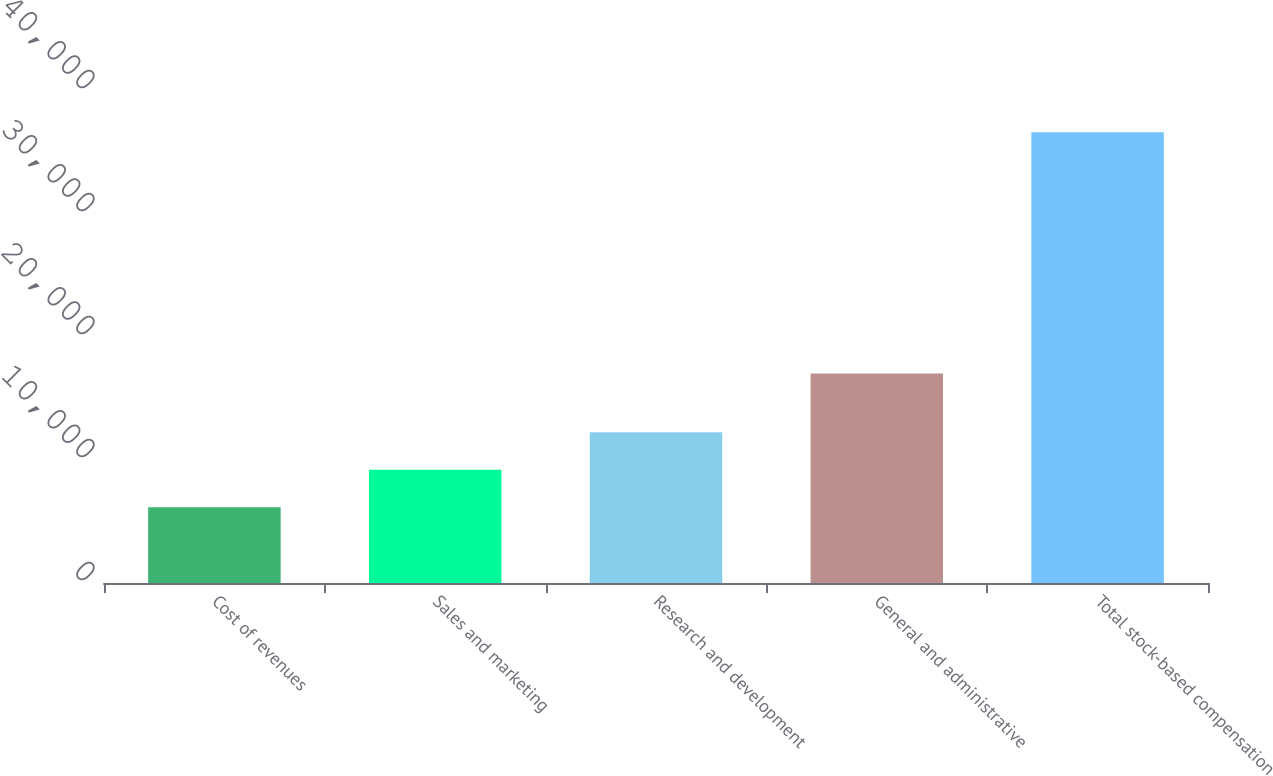Convert chart. <chart><loc_0><loc_0><loc_500><loc_500><bar_chart><fcel>Cost of revenues<fcel>Sales and marketing<fcel>Research and development<fcel>General and administrative<fcel>Total stock-based compensation<nl><fcel>6156<fcel>9205.3<fcel>12254.6<fcel>17042<fcel>36649<nl></chart> 